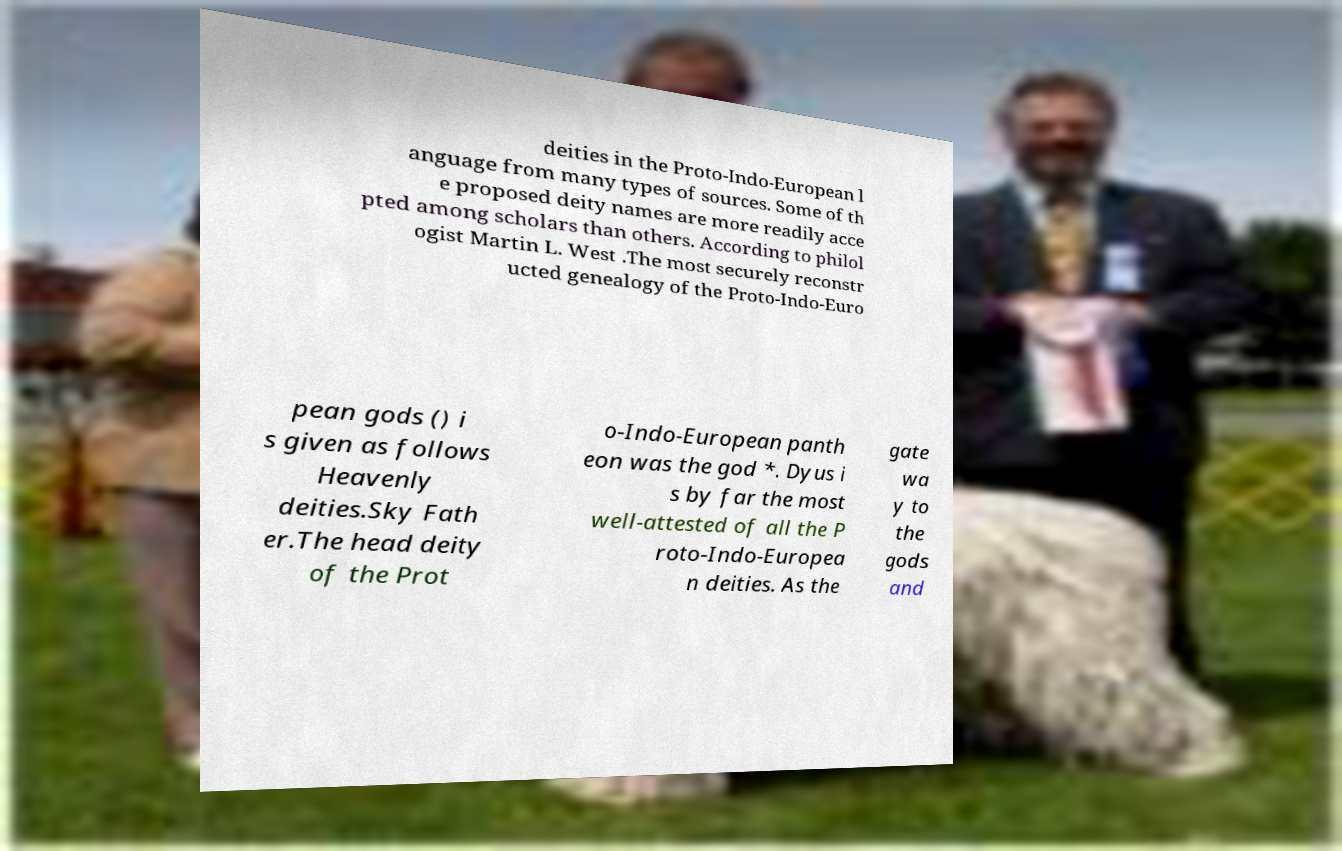Can you accurately transcribe the text from the provided image for me? deities in the Proto-Indo-European l anguage from many types of sources. Some of th e proposed deity names are more readily acce pted among scholars than others. According to philol ogist Martin L. West .The most securely reconstr ucted genealogy of the Proto-Indo-Euro pean gods () i s given as follows Heavenly deities.Sky Fath er.The head deity of the Prot o-Indo-European panth eon was the god *. Dyus i s by far the most well-attested of all the P roto-Indo-Europea n deities. As the gate wa y to the gods and 